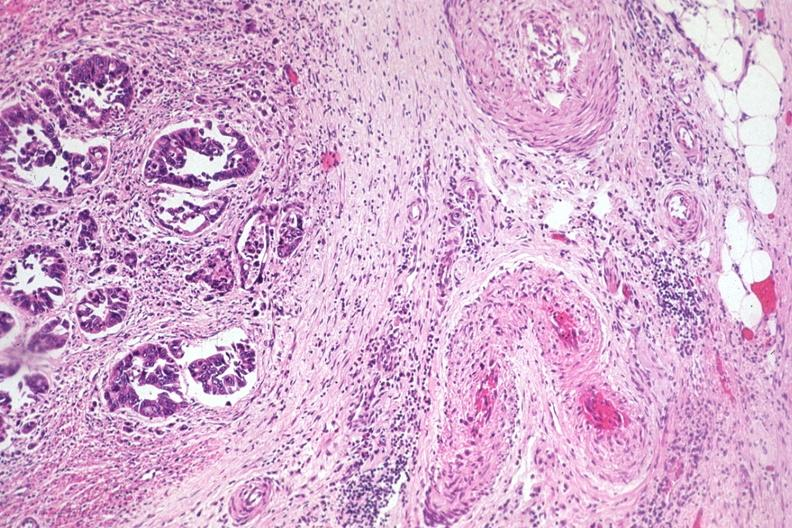does this image show typical infiltrating adenocarcinoma extending to serosal fat?
Answer the question using a single word or phrase. Yes 